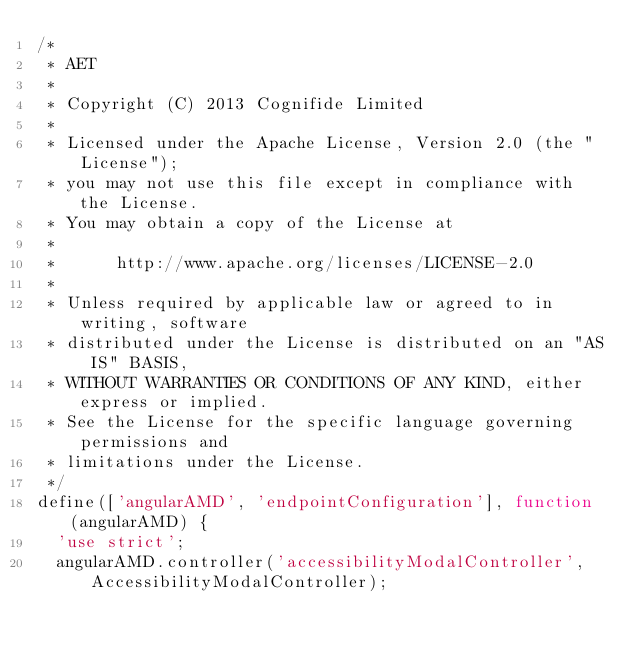<code> <loc_0><loc_0><loc_500><loc_500><_JavaScript_>/*
 * AET
 *
 * Copyright (C) 2013 Cognifide Limited
 *
 * Licensed under the Apache License, Version 2.0 (the "License");
 * you may not use this file except in compliance with the License.
 * You may obtain a copy of the License at
 *
 *      http://www.apache.org/licenses/LICENSE-2.0
 *
 * Unless required by applicable law or agreed to in writing, software
 * distributed under the License is distributed on an "AS IS" BASIS,
 * WITHOUT WARRANTIES OR CONDITIONS OF ANY KIND, either express or implied.
 * See the License for the specific language governing permissions and
 * limitations under the License.
 */
define(['angularAMD', 'endpointConfiguration'], function (angularAMD) {
  'use strict';
  angularAMD.controller('accessibilityModalController', AccessibilityModalController);
</code> 